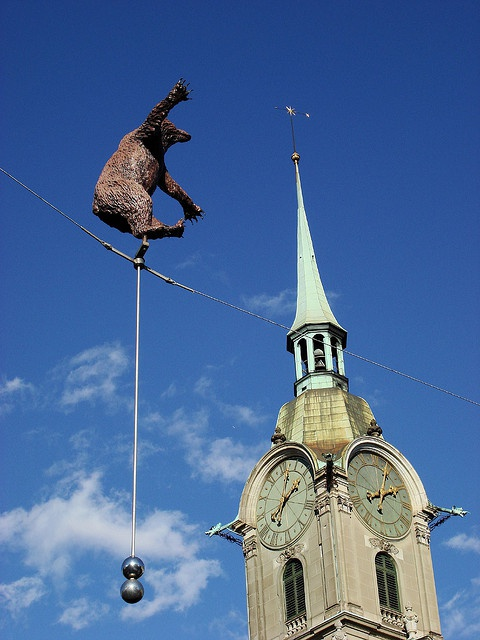Describe the objects in this image and their specific colors. I can see bear in darkblue, black, gray, and maroon tones, clock in darkblue, darkgray, gray, and beige tones, and clock in darkblue, darkgray, gray, and black tones in this image. 